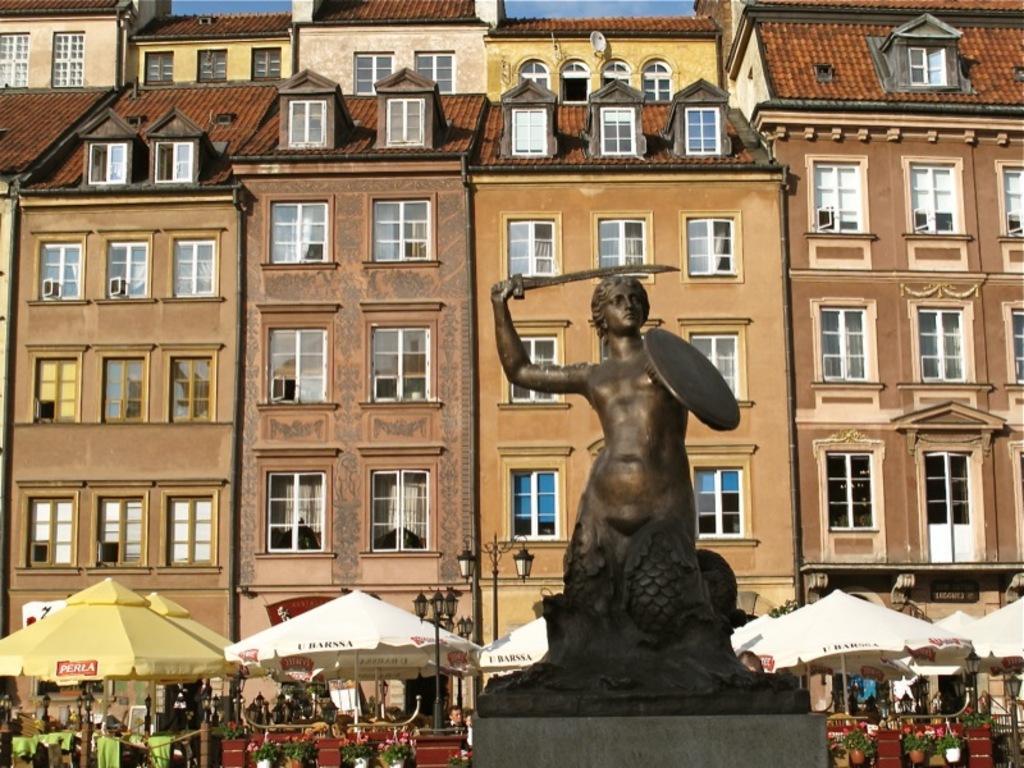How would you summarize this image in a sentence or two? In the foreground I can see a statue of a person, tents, houseplants and poles. In the background I can see buildings and windows. At the top I can see the sky. This image is taken may be on the road. 